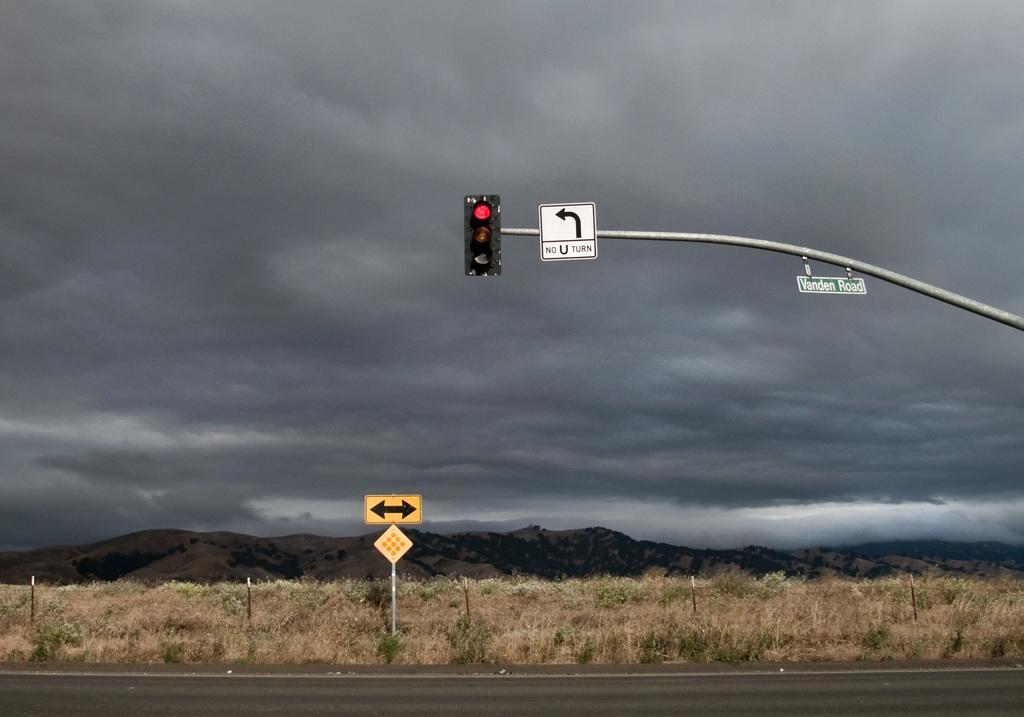How would you summarize this image in a sentence or two? In this image, in the middle there is a traffic signal, sign board, text board and pole. At the bottom there are signboard, pole, grass, road, hills, sky and clouds. 